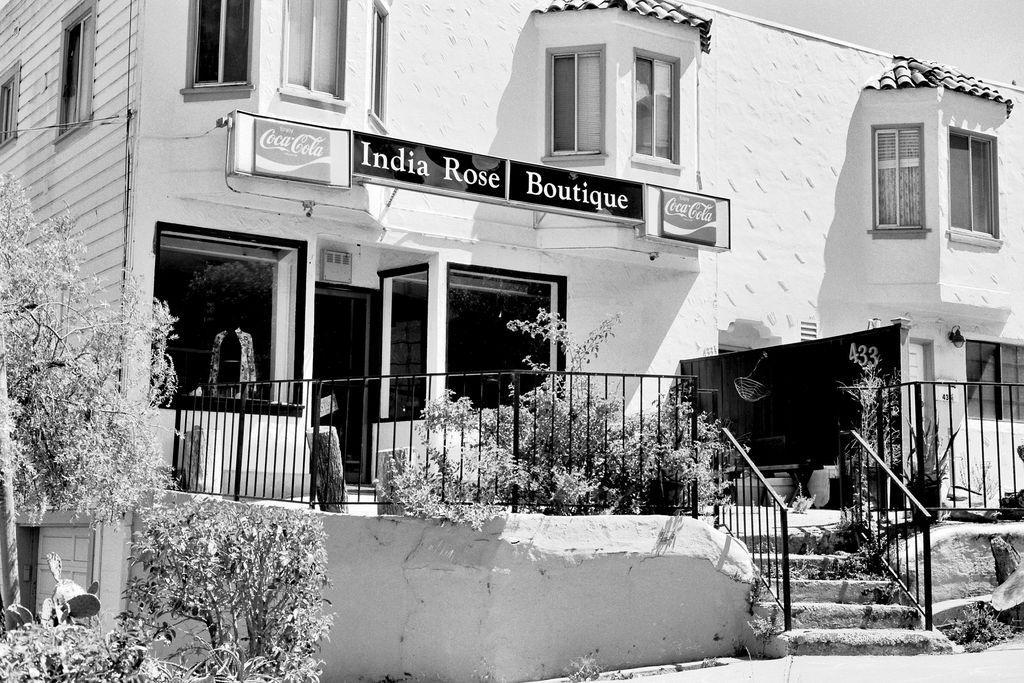Can you describe this image briefly? Black and white picture. In this picture we can see a tree, plants, steps, railings, building, sky and hoardings.   